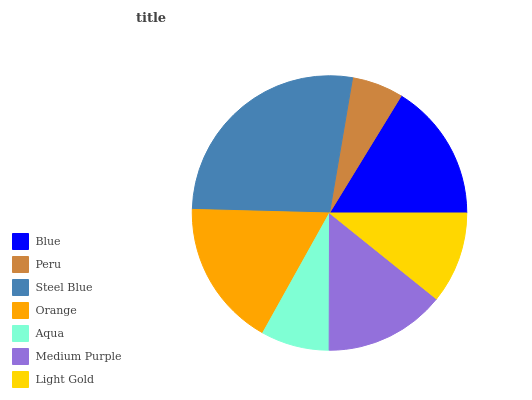Is Peru the minimum?
Answer yes or no. Yes. Is Steel Blue the maximum?
Answer yes or no. Yes. Is Steel Blue the minimum?
Answer yes or no. No. Is Peru the maximum?
Answer yes or no. No. Is Steel Blue greater than Peru?
Answer yes or no. Yes. Is Peru less than Steel Blue?
Answer yes or no. Yes. Is Peru greater than Steel Blue?
Answer yes or no. No. Is Steel Blue less than Peru?
Answer yes or no. No. Is Medium Purple the high median?
Answer yes or no. Yes. Is Medium Purple the low median?
Answer yes or no. Yes. Is Orange the high median?
Answer yes or no. No. Is Orange the low median?
Answer yes or no. No. 